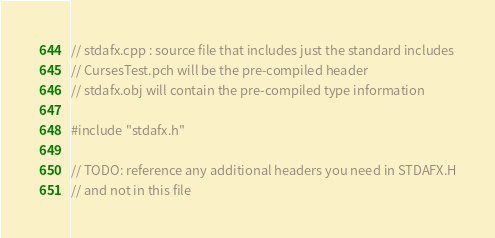Convert code to text. <code><loc_0><loc_0><loc_500><loc_500><_C_>// stdafx.cpp : source file that includes just the standard includes
// CursesTest.pch will be the pre-compiled header
// stdafx.obj will contain the pre-compiled type information

#include "stdafx.h"

// TODO: reference any additional headers you need in STDAFX.H
// and not in this file
</code> 